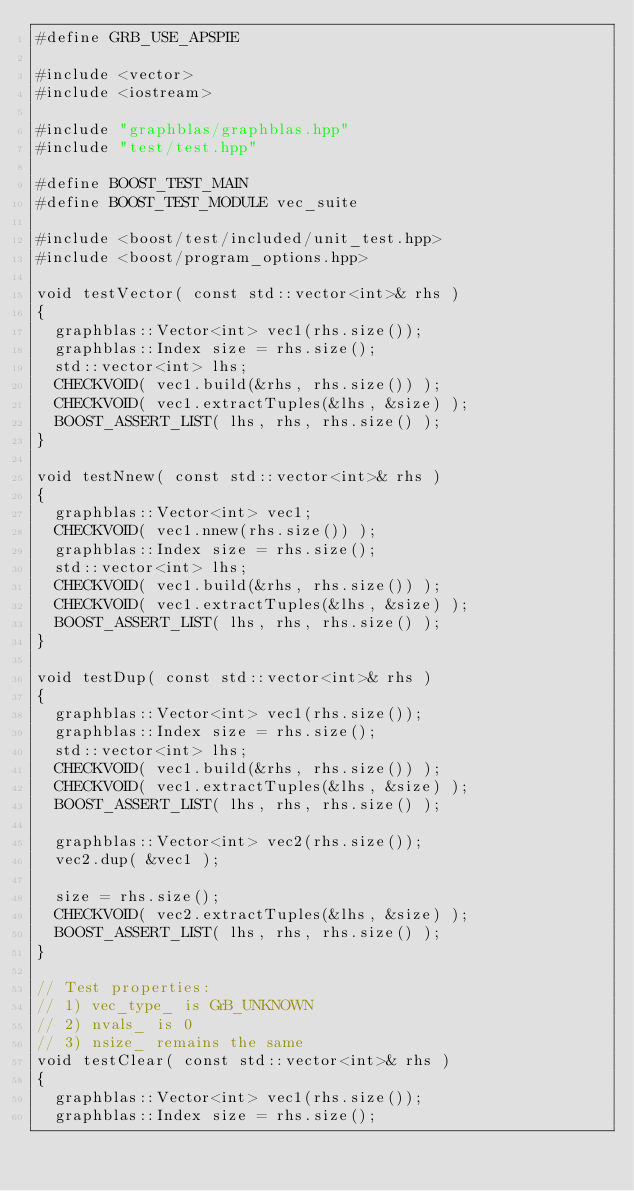<code> <loc_0><loc_0><loc_500><loc_500><_Cuda_>#define GRB_USE_APSPIE

#include <vector>
#include <iostream>

#include "graphblas/graphblas.hpp"
#include "test/test.hpp"

#define BOOST_TEST_MAIN
#define BOOST_TEST_MODULE vec_suite

#include <boost/test/included/unit_test.hpp>
#include <boost/program_options.hpp>

void testVector( const std::vector<int>& rhs )
{
  graphblas::Vector<int> vec1(rhs.size());
  graphblas::Index size = rhs.size();
  std::vector<int> lhs;
  CHECKVOID( vec1.build(&rhs, rhs.size()) );
  CHECKVOID( vec1.extractTuples(&lhs, &size) );
  BOOST_ASSERT_LIST( lhs, rhs, rhs.size() );
}

void testNnew( const std::vector<int>& rhs )
{
  graphblas::Vector<int> vec1;
  CHECKVOID( vec1.nnew(rhs.size()) );
  graphblas::Index size = rhs.size();
  std::vector<int> lhs;
  CHECKVOID( vec1.build(&rhs, rhs.size()) );
  CHECKVOID( vec1.extractTuples(&lhs, &size) );
  BOOST_ASSERT_LIST( lhs, rhs, rhs.size() );
}

void testDup( const std::vector<int>& rhs )
{
  graphblas::Vector<int> vec1(rhs.size());
  graphblas::Index size = rhs.size();
  std::vector<int> lhs;
  CHECKVOID( vec1.build(&rhs, rhs.size()) );
  CHECKVOID( vec1.extractTuples(&lhs, &size) );
  BOOST_ASSERT_LIST( lhs, rhs, rhs.size() );

  graphblas::Vector<int> vec2(rhs.size());
  vec2.dup( &vec1 );

  size = rhs.size();
  CHECKVOID( vec2.extractTuples(&lhs, &size) );
  BOOST_ASSERT_LIST( lhs, rhs, rhs.size() );
}

// Test properties:
// 1) vec_type_ is GrB_UNKNOWN
// 2) nvals_ is 0
// 3) nsize_ remains the same
void testClear( const std::vector<int>& rhs )
{
  graphblas::Vector<int> vec1(rhs.size());
  graphblas::Index size = rhs.size();</code> 